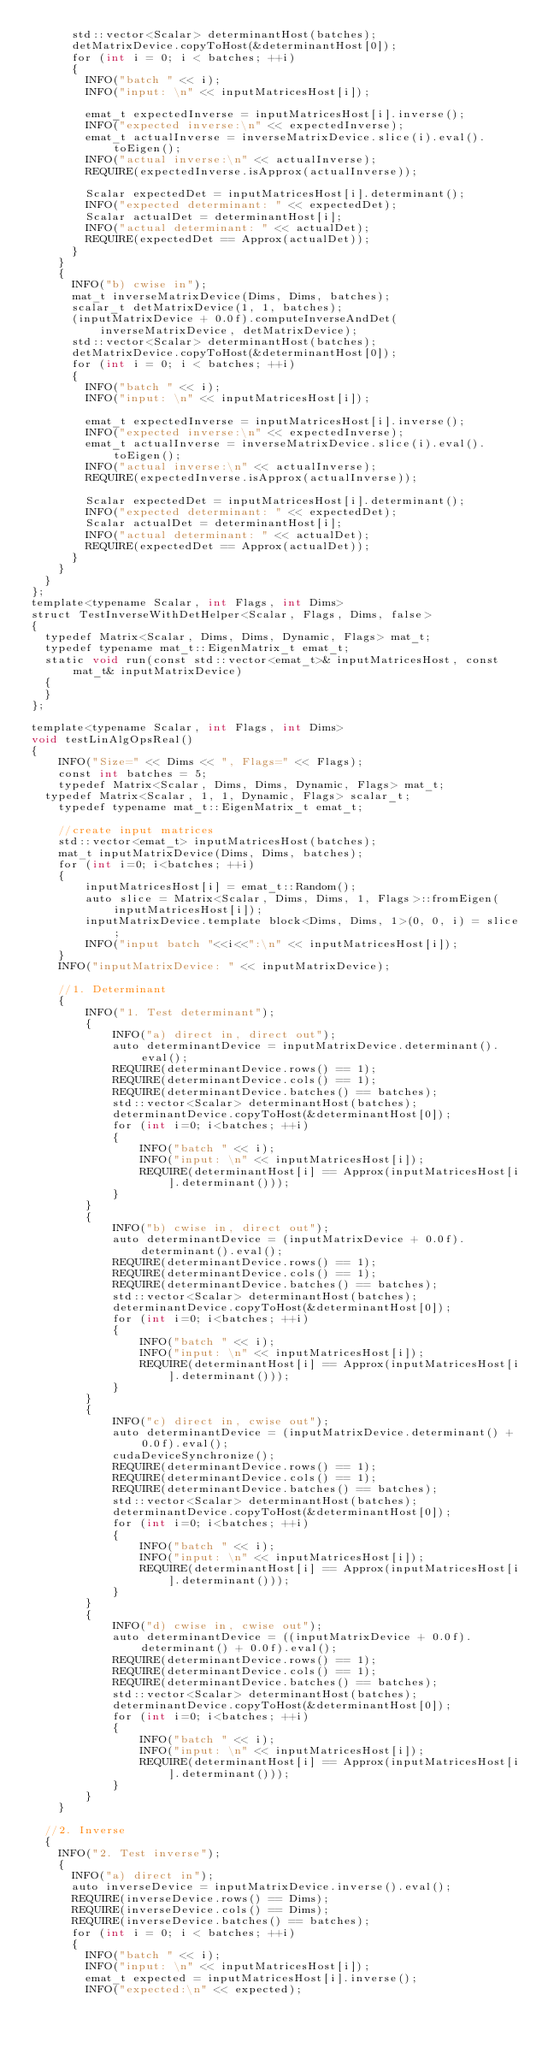<code> <loc_0><loc_0><loc_500><loc_500><_Cuda_>			std::vector<Scalar> determinantHost(batches);
			detMatrixDevice.copyToHost(&determinantHost[0]);
			for (int i = 0; i < batches; ++i)
			{
				INFO("batch " << i);
				INFO("input: \n" << inputMatricesHost[i]);

				emat_t expectedInverse = inputMatricesHost[i].inverse();
				INFO("expected inverse:\n" << expectedInverse);
				emat_t actualInverse = inverseMatrixDevice.slice(i).eval().toEigen();
				INFO("actual inverse:\n" << actualInverse);
				REQUIRE(expectedInverse.isApprox(actualInverse));

				Scalar expectedDet = inputMatricesHost[i].determinant();
				INFO("expected determinant: " << expectedDet);
				Scalar actualDet = determinantHost[i];
				INFO("actual determinant: " << actualDet);
				REQUIRE(expectedDet == Approx(actualDet));
			}
		}
		{
			INFO("b) cwise in");
			mat_t inverseMatrixDevice(Dims, Dims, batches);
			scalar_t detMatrixDevice(1, 1, batches);
			(inputMatrixDevice + 0.0f).computeInverseAndDet(inverseMatrixDevice, detMatrixDevice);
			std::vector<Scalar> determinantHost(batches);
			detMatrixDevice.copyToHost(&determinantHost[0]);
			for (int i = 0; i < batches; ++i)
			{
				INFO("batch " << i);
				INFO("input: \n" << inputMatricesHost[i]);

				emat_t expectedInverse = inputMatricesHost[i].inverse();
				INFO("expected inverse:\n" << expectedInverse);
				emat_t actualInverse = inverseMatrixDevice.slice(i).eval().toEigen();
				INFO("actual inverse:\n" << actualInverse);
				REQUIRE(expectedInverse.isApprox(actualInverse));

				Scalar expectedDet = inputMatricesHost[i].determinant();
				INFO("expected determinant: " << expectedDet);
				Scalar actualDet = determinantHost[i];
				INFO("actual determinant: " << actualDet);
				REQUIRE(expectedDet == Approx(actualDet));
			}
		}
	}
};
template<typename Scalar, int Flags, int Dims>
struct TestInverseWithDetHelper<Scalar, Flags, Dims, false>
{
	typedef Matrix<Scalar, Dims, Dims, Dynamic, Flags> mat_t;
	typedef typename mat_t::EigenMatrix_t emat_t;
	static void run(const std::vector<emat_t>& inputMatricesHost, const mat_t& inputMatrixDevice)
	{
	}
};

template<typename Scalar, int Flags, int Dims>
void testLinAlgOpsReal()
{
    INFO("Size=" << Dims << ", Flags=" << Flags);
    const int batches = 5;
    typedef Matrix<Scalar, Dims, Dims, Dynamic, Flags> mat_t;
	typedef Matrix<Scalar, 1, 1, Dynamic, Flags> scalar_t;
    typedef typename mat_t::EigenMatrix_t emat_t;

    //create input matrices
    std::vector<emat_t> inputMatricesHost(batches);
    mat_t inputMatrixDevice(Dims, Dims, batches);
    for (int i=0; i<batches; ++i)
    {
        inputMatricesHost[i] = emat_t::Random();
        auto slice = Matrix<Scalar, Dims, Dims, 1, Flags>::fromEigen(inputMatricesHost[i]);
        inputMatrixDevice.template block<Dims, Dims, 1>(0, 0, i) = slice;
        INFO("input batch "<<i<<":\n" << inputMatricesHost[i]);
    }
    INFO("inputMatrixDevice: " << inputMatrixDevice);

    //1. Determinant
    {
        INFO("1. Test determinant");
        {
            INFO("a) direct in, direct out");
            auto determinantDevice = inputMatrixDevice.determinant().eval();
            REQUIRE(determinantDevice.rows() == 1);
            REQUIRE(determinantDevice.cols() == 1);
            REQUIRE(determinantDevice.batches() == batches);
            std::vector<Scalar> determinantHost(batches);
            determinantDevice.copyToHost(&determinantHost[0]);
            for (int i=0; i<batches; ++i)
            {
                INFO("batch " << i);
                INFO("input: \n" << inputMatricesHost[i]);
                REQUIRE(determinantHost[i] == Approx(inputMatricesHost[i].determinant()));
            }
        }
        {
            INFO("b) cwise in, direct out");
            auto determinantDevice = (inputMatrixDevice + 0.0f).determinant().eval();
            REQUIRE(determinantDevice.rows() == 1);
            REQUIRE(determinantDevice.cols() == 1);
            REQUIRE(determinantDevice.batches() == batches);
            std::vector<Scalar> determinantHost(batches);
            determinantDevice.copyToHost(&determinantHost[0]);
            for (int i=0; i<batches; ++i)
            {
                INFO("batch " << i);
                INFO("input: \n" << inputMatricesHost[i]);
                REQUIRE(determinantHost[i] == Approx(inputMatricesHost[i].determinant()));
            }
        }
        {
            INFO("c) direct in, cwise out");
            auto determinantDevice = (inputMatrixDevice.determinant() + 0.0f).eval();
            cudaDeviceSynchronize();
            REQUIRE(determinantDevice.rows() == 1);
            REQUIRE(determinantDevice.cols() == 1);
            REQUIRE(determinantDevice.batches() == batches);
            std::vector<Scalar> determinantHost(batches);
            determinantDevice.copyToHost(&determinantHost[0]);
            for (int i=0; i<batches; ++i)
            {
                INFO("batch " << i);
                INFO("input: \n" << inputMatricesHost[i]);
                REQUIRE(determinantHost[i] == Approx(inputMatricesHost[i].determinant()));
            }
        }
        {
            INFO("d) cwise in, cwise out");
            auto determinantDevice = ((inputMatrixDevice + 0.0f).determinant() + 0.0f).eval();
            REQUIRE(determinantDevice.rows() == 1);
            REQUIRE(determinantDevice.cols() == 1);
            REQUIRE(determinantDevice.batches() == batches);
            std::vector<Scalar> determinantHost(batches);
            determinantDevice.copyToHost(&determinantHost[0]);
            for (int i=0; i<batches; ++i)
            {
                INFO("batch " << i);
                INFO("input: \n" << inputMatricesHost[i]);
                REQUIRE(determinantHost[i] == Approx(inputMatricesHost[i].determinant()));
            }
        }
    }

	//2. Inverse
	{
		INFO("2. Test inverse");
		{
			INFO("a) direct in");
			auto inverseDevice = inputMatrixDevice.inverse().eval();
			REQUIRE(inverseDevice.rows() == Dims);
			REQUIRE(inverseDevice.cols() == Dims);
			REQUIRE(inverseDevice.batches() == batches);
			for (int i = 0; i < batches; ++i)
			{
				INFO("batch " << i);
				INFO("input: \n" << inputMatricesHost[i]);
				emat_t expected = inputMatricesHost[i].inverse();
				INFO("expected:\n" << expected);</code> 